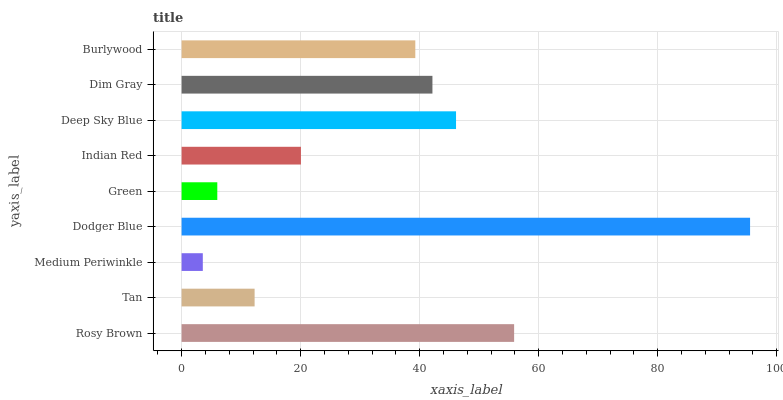Is Medium Periwinkle the minimum?
Answer yes or no. Yes. Is Dodger Blue the maximum?
Answer yes or no. Yes. Is Tan the minimum?
Answer yes or no. No. Is Tan the maximum?
Answer yes or no. No. Is Rosy Brown greater than Tan?
Answer yes or no. Yes. Is Tan less than Rosy Brown?
Answer yes or no. Yes. Is Tan greater than Rosy Brown?
Answer yes or no. No. Is Rosy Brown less than Tan?
Answer yes or no. No. Is Burlywood the high median?
Answer yes or no. Yes. Is Burlywood the low median?
Answer yes or no. Yes. Is Dodger Blue the high median?
Answer yes or no. No. Is Rosy Brown the low median?
Answer yes or no. No. 